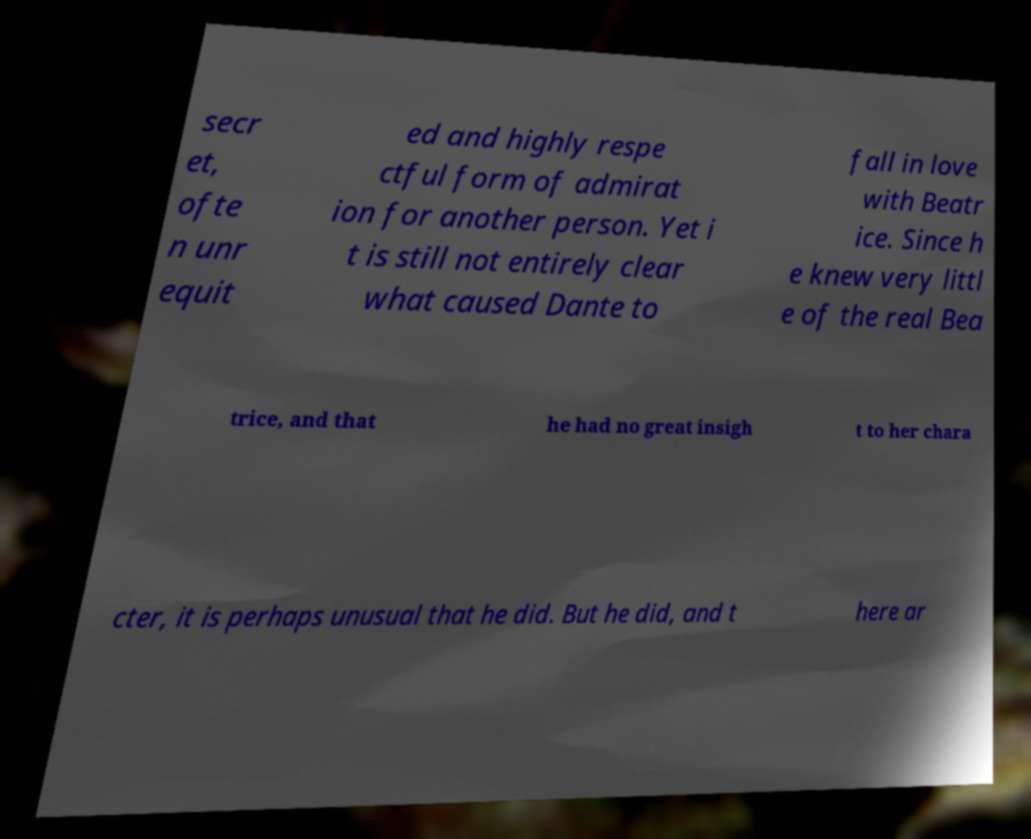Could you extract and type out the text from this image? secr et, ofte n unr equit ed and highly respe ctful form of admirat ion for another person. Yet i t is still not entirely clear what caused Dante to fall in love with Beatr ice. Since h e knew very littl e of the real Bea trice, and that he had no great insigh t to her chara cter, it is perhaps unusual that he did. But he did, and t here ar 